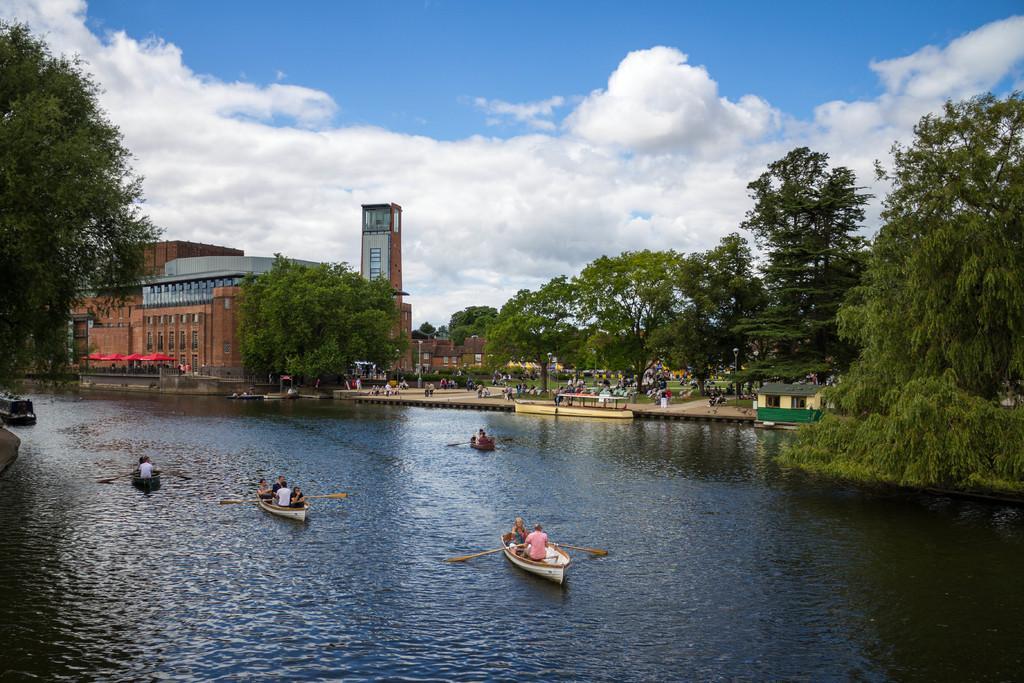Could you give a brief overview of what you see in this image? This is an outside view. At the bottom there is a river. There are few boats on the water and I can see people sitting on the boats. In the background there are many trees and buildings. In the middle of the image I can see many people on the ground. It seems to be a garden. At the top of the image I can see the sky and clouds. 